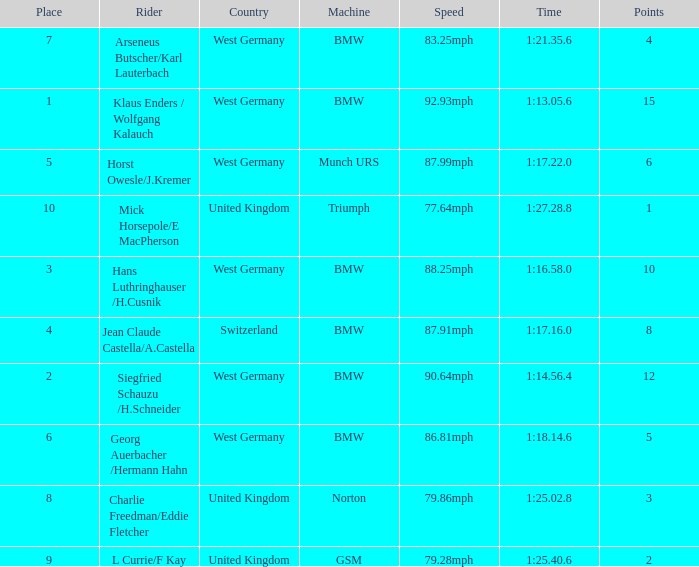Which places have points larger than 10? None. 